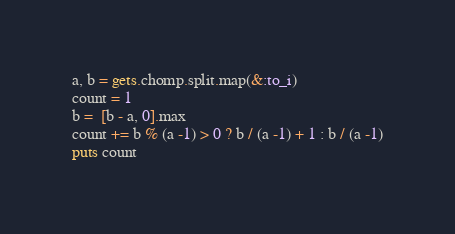<code> <loc_0><loc_0><loc_500><loc_500><_Ruby_>a, b = gets.chomp.split.map(&:to_i)
count = 1
b =  [b - a, 0].max
count += b % (a -1) > 0 ? b / (a -1) + 1 : b / (a -1)
puts count</code> 